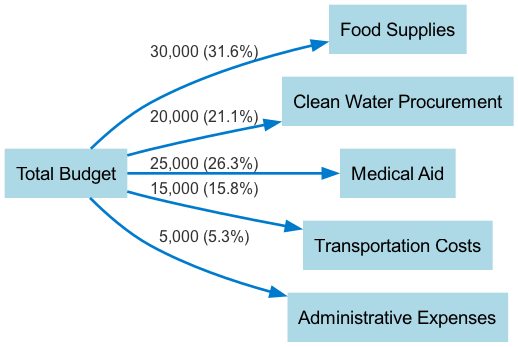What is the total budget amount? The total budget is indicated as the source node in the diagram, which is the sum of all the values in the links. By adding up the values (30000 + 20000 + 25000 + 15000 + 5000), we calculate the total budget to be 100000.
Answer: 100000 How much is allocated to food supplies? The food supplies are represented as a target node linked from the total budget node with a specified value. This value is directly given as 30000 in the diagram.
Answer: 30000 Which category has the largest allocation? To determine this, we need to compare the values of each category linked to the total budget. The highest value is from food supplies at 30000.
Answer: Food Supplies What percentage of the total budget is allocated to medical aid? We calculate the percentage by taking the medical aid value (25000), dividing it by the total budget (100000), and multiplying by 100. This gives us (25000 / 100000) * 100 = 25.0%.
Answer: 25.0% What is the combined budget for clean water procurement and transportation costs? We find the allocated amounts for clean water procurement (20000) and transportation costs (15000) from their respective links. Adding these gives 20000 + 15000 = 35000.
Answer: 35000 How many nodes does this diagram contain? The number of nodes refers to all distinct entities represented in the diagram. There are six nodes total: Total Budget, Food Supplies, Clean Water Procurement, Medical Aid, Transportation Costs, and Administrative Expenses.
Answer: 6 How are administrative expenses linked to the total budget? The administrative expenses node is a target node connected to the total budget node through a link that specifies the value. This link indicates that 5000 is allocated from the total budget to administrative expenses.
Answer: By a direct link with a value of 5000 What is the total allocation for essential aid categories (food, water, and medical)? To find the total allocation for food, clean water, and medical aid, we sum their respective allocations (30000 + 20000 + 25000). This results in a total of 75000 allocated to essential aid categories.
Answer: 75000 What is the proportion of transportation costs compared to the total budget? The proportion is calculated by taking the transportation cost (15000), dividing by the total budget (100000), and expressing it as a percentage. This results in (15000 / 100000) * 100 = 15.0%.
Answer: 15.0% 